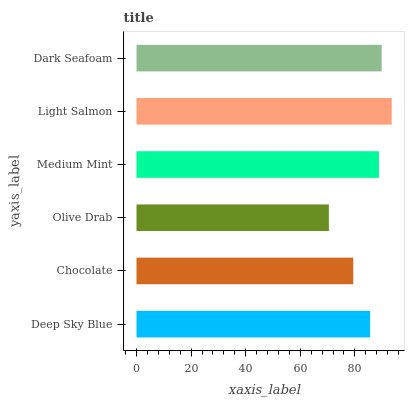Is Olive Drab the minimum?
Answer yes or no. Yes. Is Light Salmon the maximum?
Answer yes or no. Yes. Is Chocolate the minimum?
Answer yes or no. No. Is Chocolate the maximum?
Answer yes or no. No. Is Deep Sky Blue greater than Chocolate?
Answer yes or no. Yes. Is Chocolate less than Deep Sky Blue?
Answer yes or no. Yes. Is Chocolate greater than Deep Sky Blue?
Answer yes or no. No. Is Deep Sky Blue less than Chocolate?
Answer yes or no. No. Is Medium Mint the high median?
Answer yes or no. Yes. Is Deep Sky Blue the low median?
Answer yes or no. Yes. Is Deep Sky Blue the high median?
Answer yes or no. No. Is Dark Seafoam the low median?
Answer yes or no. No. 